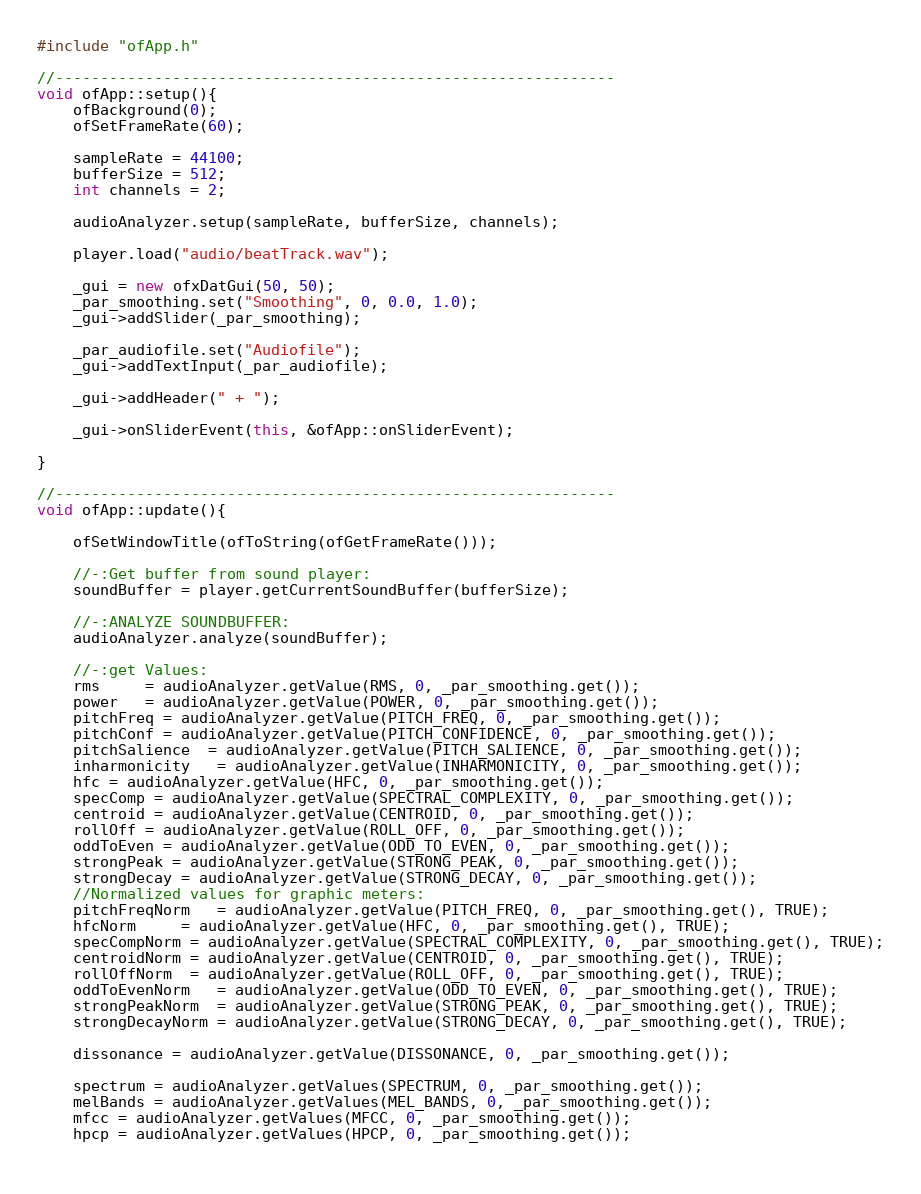Convert code to text. <code><loc_0><loc_0><loc_500><loc_500><_C++_>#include "ofApp.h"

//--------------------------------------------------------------
void ofApp::setup(){
    ofBackground(0);
    ofSetFrameRate(60);
    
    sampleRate = 44100;
    bufferSize = 512;
    int channels = 2;
    
    audioAnalyzer.setup(sampleRate, bufferSize, channels);
    
    player.load("audio/beatTrack.wav");

    _gui = new ofxDatGui(50, 50);
    _par_smoothing.set("Smoothing", 0, 0.0, 1.0);
    _gui->addSlider(_par_smoothing);

    _par_audiofile.set("Audiofile");
    _gui->addTextInput(_par_audiofile);

    _gui->addHeader(" + ");

    _gui->onSliderEvent(this, &ofApp::onSliderEvent);
   
}

//--------------------------------------------------------------
void ofApp::update(){
    
    ofSetWindowTitle(ofToString(ofGetFrameRate()));
    
    //-:Get buffer from sound player:
    soundBuffer = player.getCurrentSoundBuffer(bufferSize);
    
    //-:ANALYZE SOUNDBUFFER:
    audioAnalyzer.analyze(soundBuffer);
    
    //-:get Values:
    rms     = audioAnalyzer.getValue(RMS, 0, _par_smoothing.get());
    power   = audioAnalyzer.getValue(POWER, 0, _par_smoothing.get());
    pitchFreq = audioAnalyzer.getValue(PITCH_FREQ, 0, _par_smoothing.get());
    pitchConf = audioAnalyzer.getValue(PITCH_CONFIDENCE, 0, _par_smoothing.get());
    pitchSalience  = audioAnalyzer.getValue(PITCH_SALIENCE, 0, _par_smoothing.get());
    inharmonicity   = audioAnalyzer.getValue(INHARMONICITY, 0, _par_smoothing.get());
    hfc = audioAnalyzer.getValue(HFC, 0, _par_smoothing.get());
    specComp = audioAnalyzer.getValue(SPECTRAL_COMPLEXITY, 0, _par_smoothing.get());
    centroid = audioAnalyzer.getValue(CENTROID, 0, _par_smoothing.get());
    rollOff = audioAnalyzer.getValue(ROLL_OFF, 0, _par_smoothing.get());
    oddToEven = audioAnalyzer.getValue(ODD_TO_EVEN, 0, _par_smoothing.get());
    strongPeak = audioAnalyzer.getValue(STRONG_PEAK, 0, _par_smoothing.get());
    strongDecay = audioAnalyzer.getValue(STRONG_DECAY, 0, _par_smoothing.get());
    //Normalized values for graphic meters:
    pitchFreqNorm   = audioAnalyzer.getValue(PITCH_FREQ, 0, _par_smoothing.get(), TRUE);
    hfcNorm     = audioAnalyzer.getValue(HFC, 0, _par_smoothing.get(), TRUE);
    specCompNorm = audioAnalyzer.getValue(SPECTRAL_COMPLEXITY, 0, _par_smoothing.get(), TRUE);
    centroidNorm = audioAnalyzer.getValue(CENTROID, 0, _par_smoothing.get(), TRUE);
    rollOffNorm  = audioAnalyzer.getValue(ROLL_OFF, 0, _par_smoothing.get(), TRUE);
    oddToEvenNorm   = audioAnalyzer.getValue(ODD_TO_EVEN, 0, _par_smoothing.get(), TRUE);
    strongPeakNorm  = audioAnalyzer.getValue(STRONG_PEAK, 0, _par_smoothing.get(), TRUE);
    strongDecayNorm = audioAnalyzer.getValue(STRONG_DECAY, 0, _par_smoothing.get(), TRUE);
    
    dissonance = audioAnalyzer.getValue(DISSONANCE, 0, _par_smoothing.get());
    
    spectrum = audioAnalyzer.getValues(SPECTRUM, 0, _par_smoothing.get());
    melBands = audioAnalyzer.getValues(MEL_BANDS, 0, _par_smoothing.get());
    mfcc = audioAnalyzer.getValues(MFCC, 0, _par_smoothing.get());
    hpcp = audioAnalyzer.getValues(HPCP, 0, _par_smoothing.get());
    </code> 